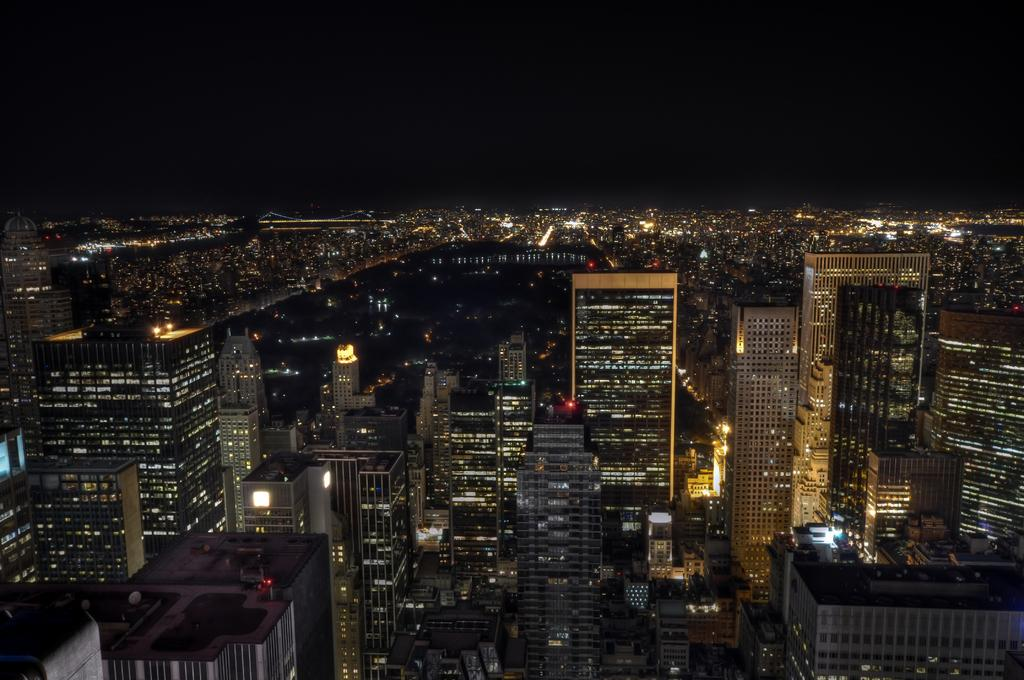What type of view is shown in the image? The image is a top view of a city. What structures can be seen in the image? There are buildings visible in the image. What type of calendar is hanging on the wall of one of the buildings in the image? There is no calendar visible in the image, as it is a top view of the city and does not show the interiors of the buildings. 